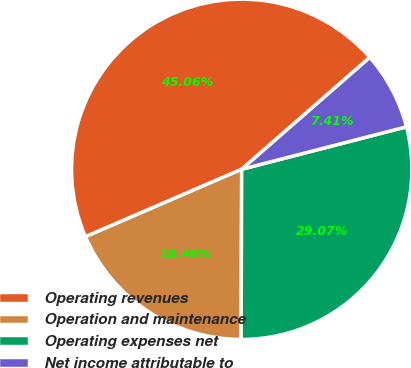Convert chart to OTSL. <chart><loc_0><loc_0><loc_500><loc_500><pie_chart><fcel>Operating revenues<fcel>Operation and maintenance<fcel>Operating expenses net<fcel>Net income attributable to<nl><fcel>45.06%<fcel>18.46%<fcel>29.07%<fcel>7.41%<nl></chart> 